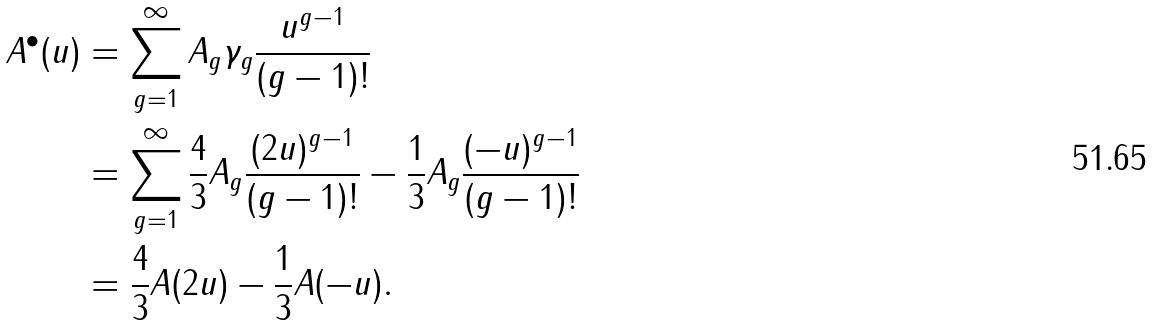<formula> <loc_0><loc_0><loc_500><loc_500>A ^ { \bullet } ( u ) & = \sum _ { g = 1 } ^ { \infty } A _ { g } \gamma _ { g } \frac { u ^ { g - 1 } } { ( g - 1 ) ! } \\ & = \sum _ { g = 1 } ^ { \infty } \frac { 4 } { 3 } A _ { g } \frac { ( 2 u ) ^ { g - 1 } } { ( g - 1 ) ! } - \frac { 1 } { 3 } A _ { g } \frac { ( - u ) ^ { g - 1 } } { ( g - 1 ) ! } \\ & = \frac { 4 } { 3 } A ( 2 u ) - \frac { 1 } { 3 } A ( - u ) .</formula> 